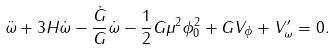Convert formula to latex. <formula><loc_0><loc_0><loc_500><loc_500>\ddot { \omega } + 3 H \dot { \omega } - \frac { \dot { G } } { G } \dot { \omega } - \frac { 1 } { 2 } G \mu ^ { 2 } \phi _ { 0 } ^ { 2 } + G V _ { \phi } + V ^ { \prime } _ { \omega } = 0 .</formula> 